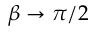<formula> <loc_0><loc_0><loc_500><loc_500>\beta \to \pi / 2</formula> 